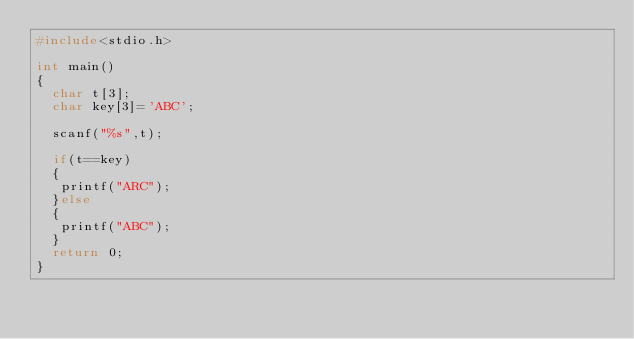Convert code to text. <code><loc_0><loc_0><loc_500><loc_500><_C_>#include<stdio.h>

int main()
{
  char t[3];
  char key[3]='ABC';
  
  scanf("%s",t);
  
  if(t==key)
  {
   printf("ARC"); 
  }else
  {
   printf("ABC"); 
  }
  return 0;
}
</code> 